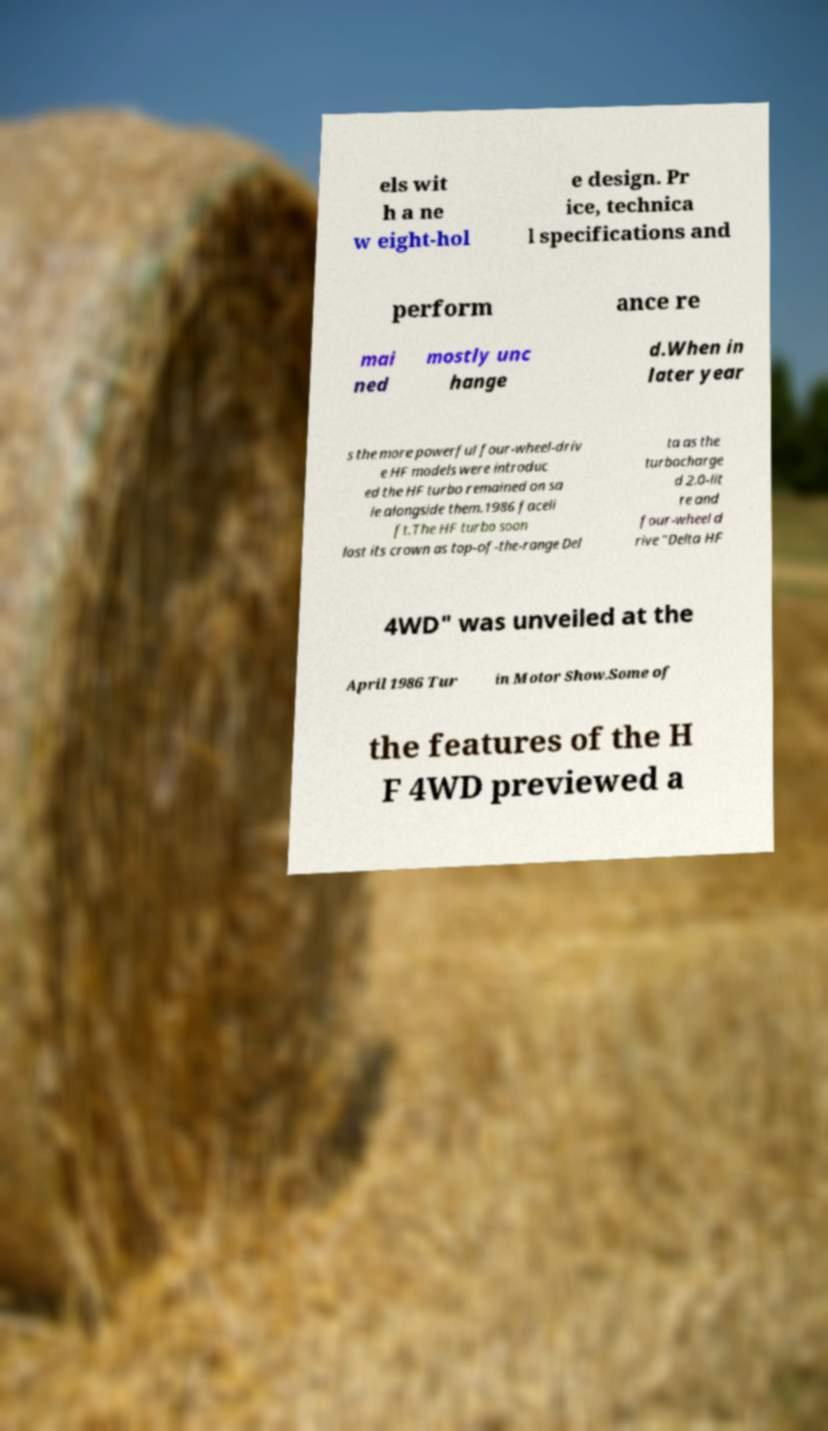What messages or text are displayed in this image? I need them in a readable, typed format. els wit h a ne w eight-hol e design. Pr ice, technica l specifications and perform ance re mai ned mostly unc hange d.When in later year s the more powerful four-wheel-driv e HF models were introduc ed the HF turbo remained on sa le alongside them.1986 faceli ft.The HF turbo soon lost its crown as top-of-the-range Del ta as the turbocharge d 2.0-lit re and four-wheel d rive "Delta HF 4WD" was unveiled at the April 1986 Tur in Motor Show.Some of the features of the H F 4WD previewed a 